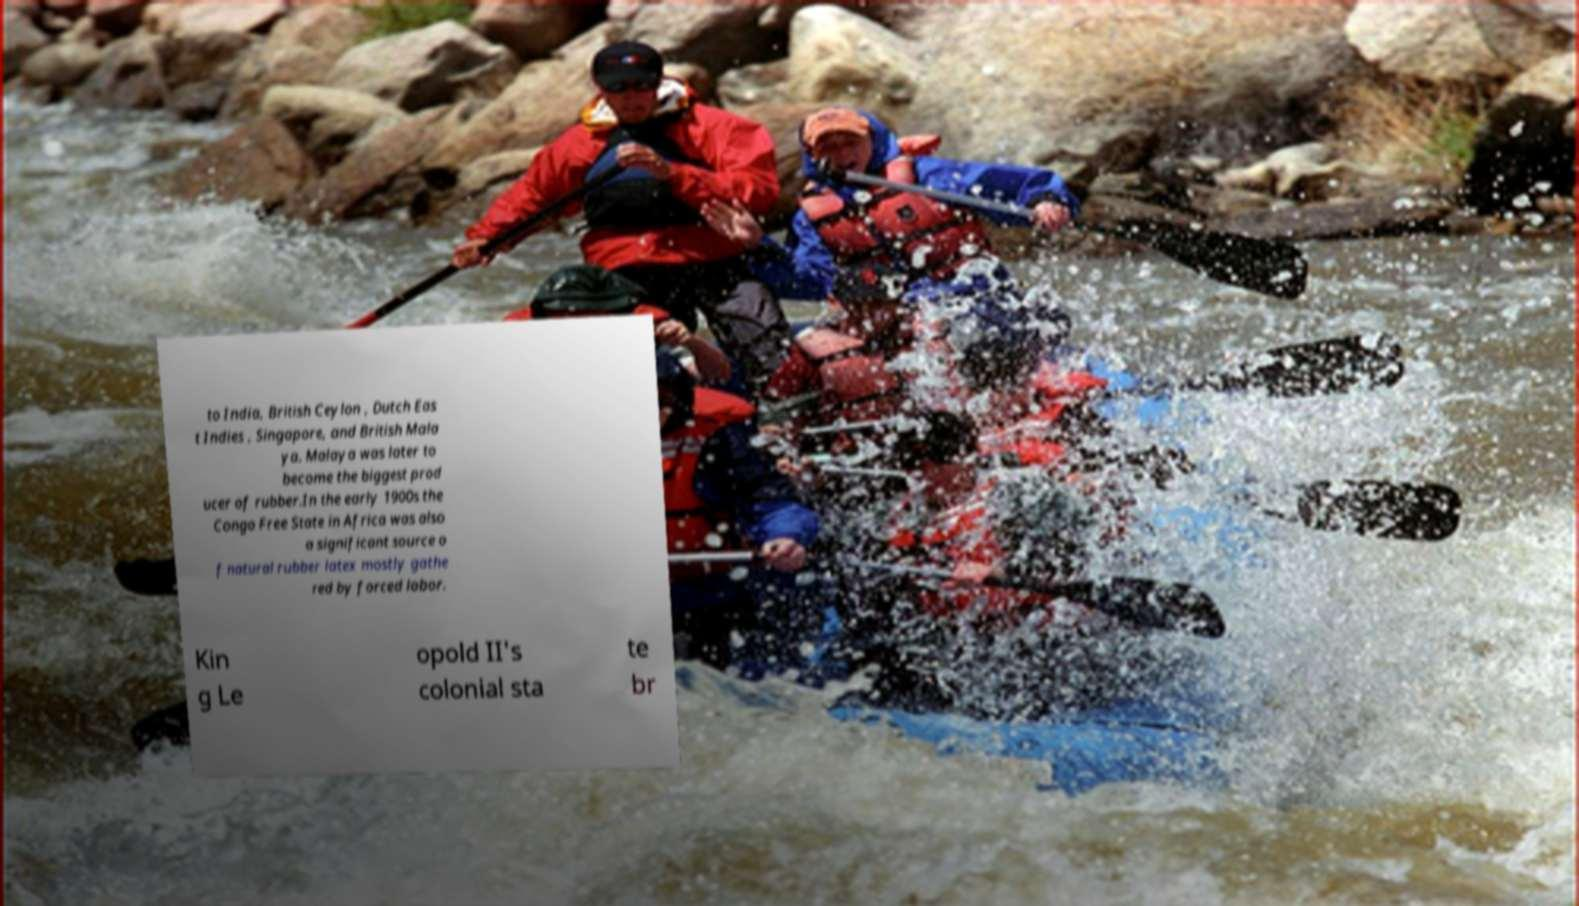Can you accurately transcribe the text from the provided image for me? to India, British Ceylon , Dutch Eas t Indies , Singapore, and British Mala ya. Malaya was later to become the biggest prod ucer of rubber.In the early 1900s the Congo Free State in Africa was also a significant source o f natural rubber latex mostly gathe red by forced labor. Kin g Le opold II's colonial sta te br 